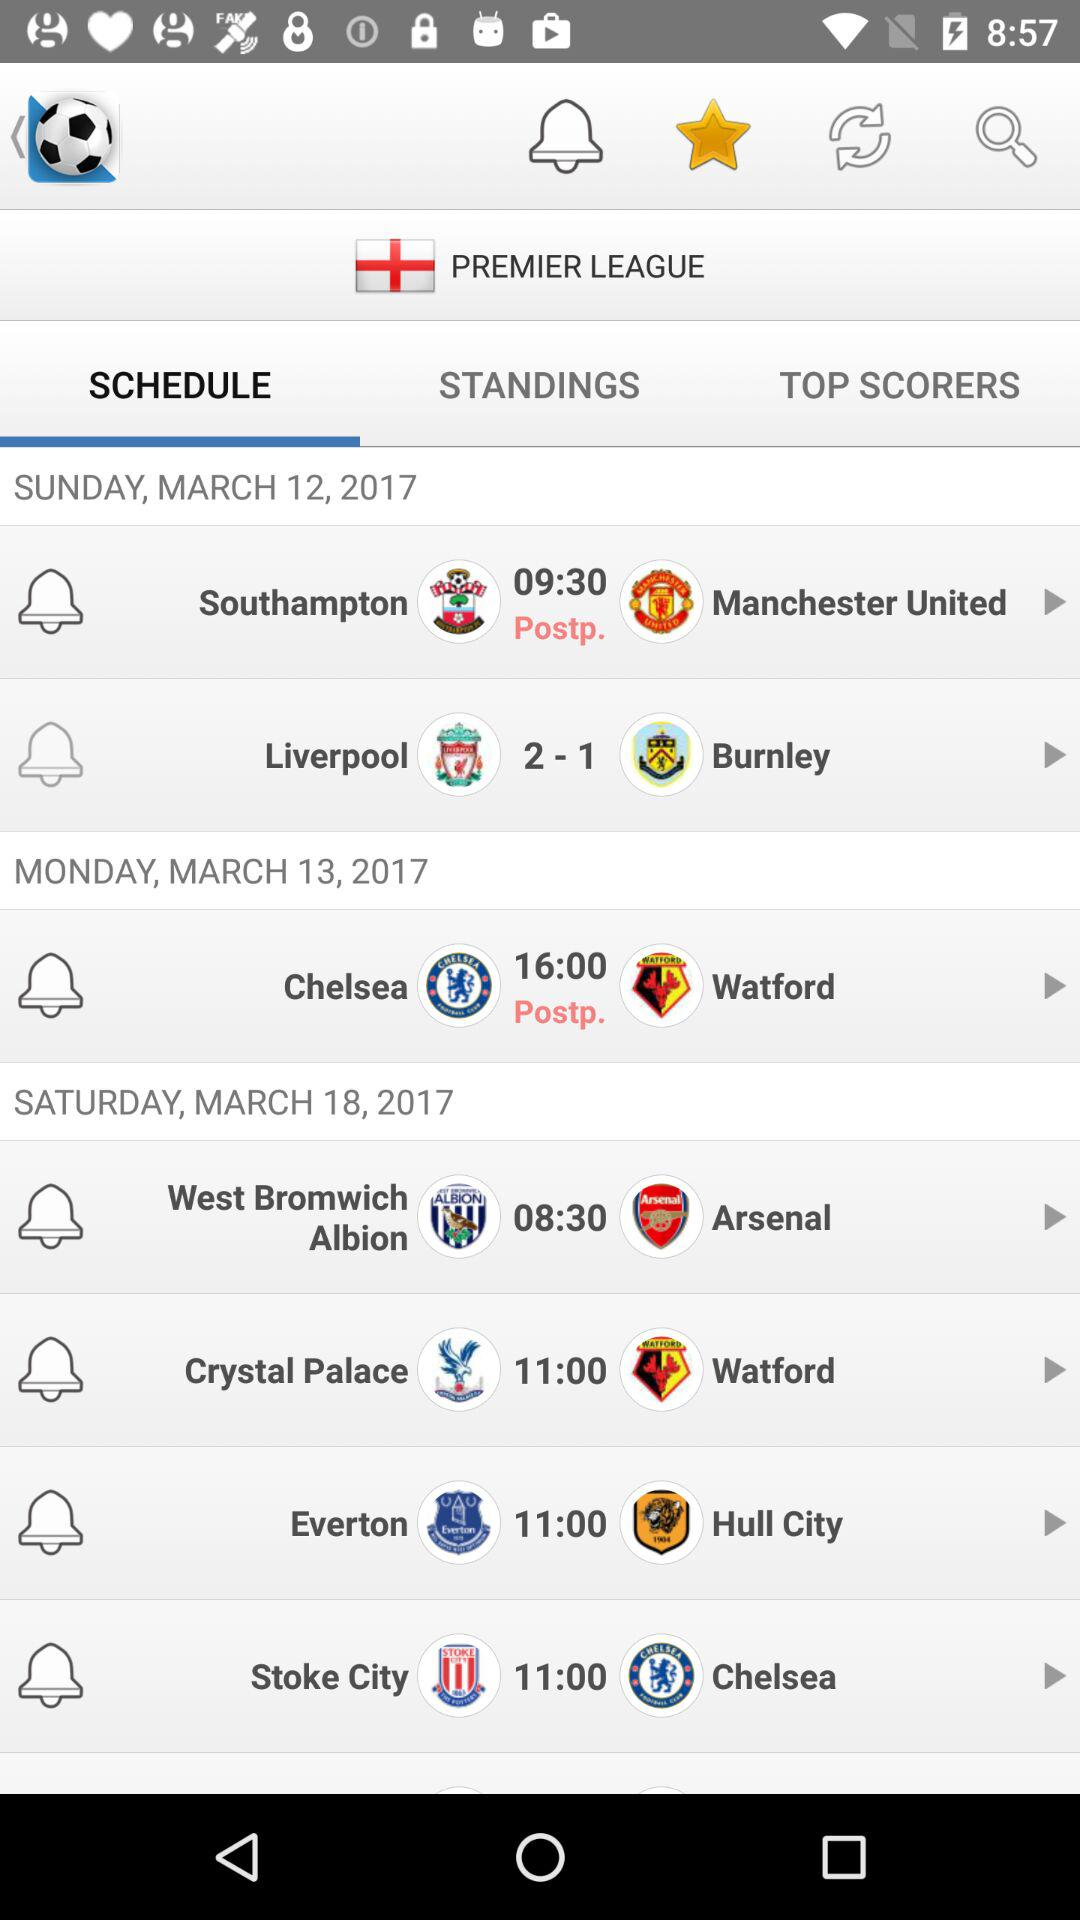What is the scheduled date and day for the "Chelsea" vs. "Watford" match? The scheduled date and day for the "Chelsea" vs. "Watford" match are March 13, 2017 and Monday, respectively. 